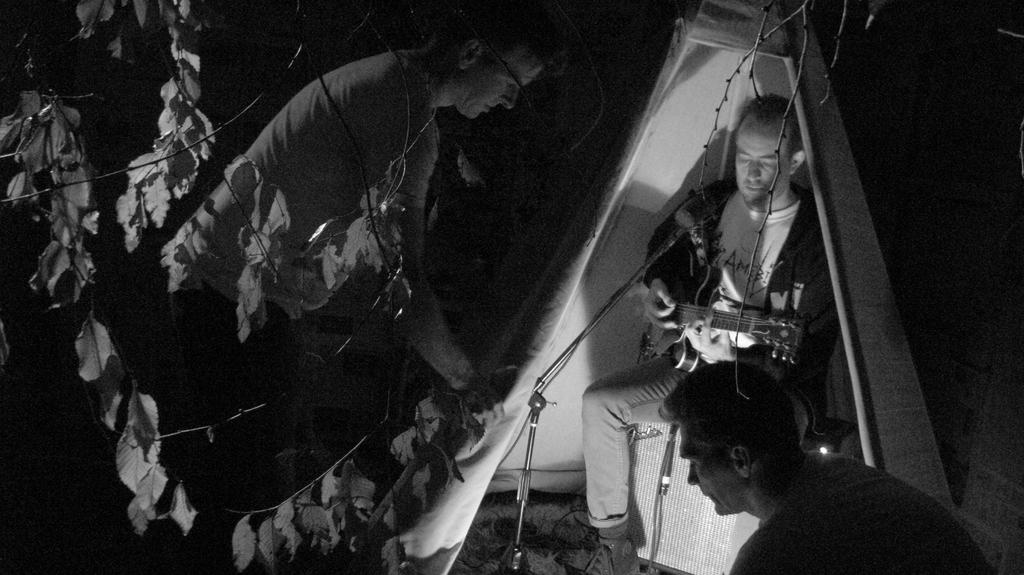How many people are in the image? There are three persons in the image. What is the man holding in the image? The man is holding a guitar. What object is in front of the man holding the guitar? There is a microphone in front of the man holding the guitar. What can be seen in the background of the image? There is a tree visible in the background of the image. What type of fuel is being used by the boat in the harbor in the image? There is no boat or harbor present in the image; it features three persons, a man holding a guitar, and a microphone. 